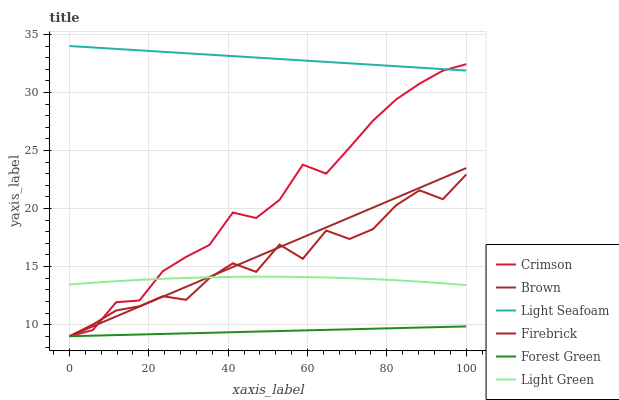Does Forest Green have the minimum area under the curve?
Answer yes or no. Yes. Does Light Seafoam have the maximum area under the curve?
Answer yes or no. Yes. Does Firebrick have the minimum area under the curve?
Answer yes or no. No. Does Firebrick have the maximum area under the curve?
Answer yes or no. No. Is Forest Green the smoothest?
Answer yes or no. Yes. Is Firebrick the roughest?
Answer yes or no. Yes. Is Firebrick the smoothest?
Answer yes or no. No. Is Forest Green the roughest?
Answer yes or no. No. Does Brown have the lowest value?
Answer yes or no. Yes. Does Light Green have the lowest value?
Answer yes or no. No. Does Light Seafoam have the highest value?
Answer yes or no. Yes. Does Firebrick have the highest value?
Answer yes or no. No. Is Brown less than Light Seafoam?
Answer yes or no. Yes. Is Light Seafoam greater than Light Green?
Answer yes or no. Yes. Does Firebrick intersect Brown?
Answer yes or no. Yes. Is Firebrick less than Brown?
Answer yes or no. No. Is Firebrick greater than Brown?
Answer yes or no. No. Does Brown intersect Light Seafoam?
Answer yes or no. No. 